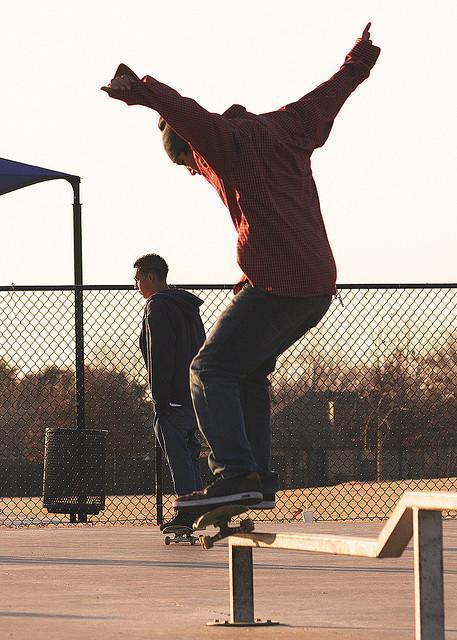How many people are in the picture?
Give a very brief answer. 2. How many of the chairs are blue?
Give a very brief answer. 0. 